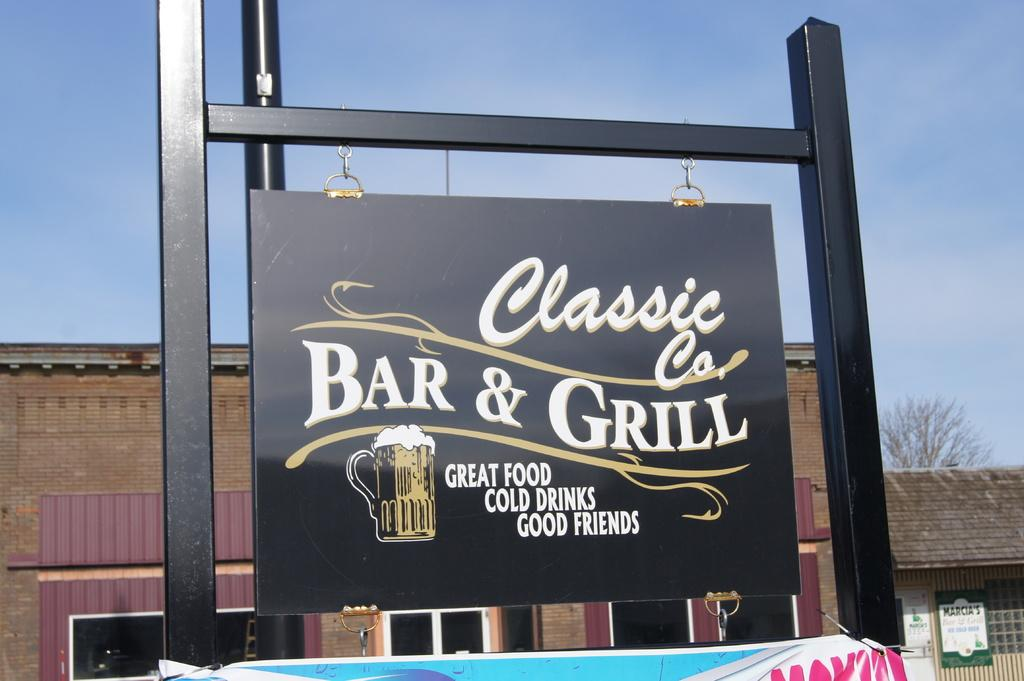<image>
Create a compact narrative representing the image presented. A large, black outdoor business placard for Classic Co. Bar and Grill 